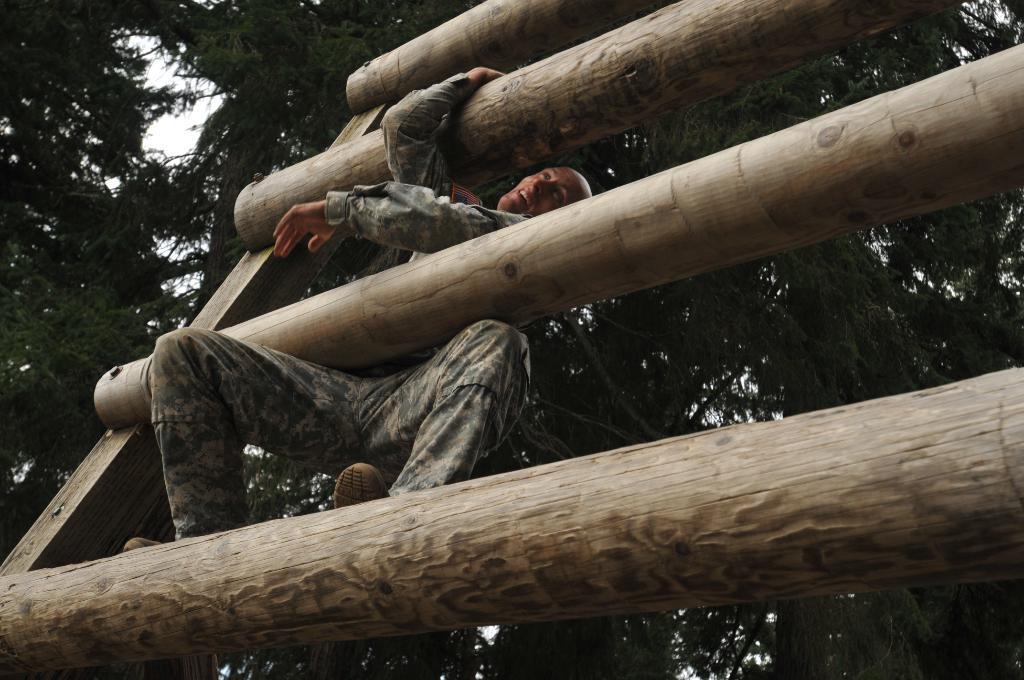In one or two sentences, can you explain what this image depicts? This picture is clicked outside. In the foreground we can see the wooden objects and we can see a man wearing a uniform and seems to be climbing the wooden object. In the background we can see the trees and some other objects. 